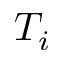Convert formula to latex. <formula><loc_0><loc_0><loc_500><loc_500>T _ { i }</formula> 